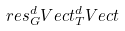Convert formula to latex. <formula><loc_0><loc_0><loc_500><loc_500>r e s ^ { d } _ { G } V e c t ^ { d } _ { T } V e c t</formula> 